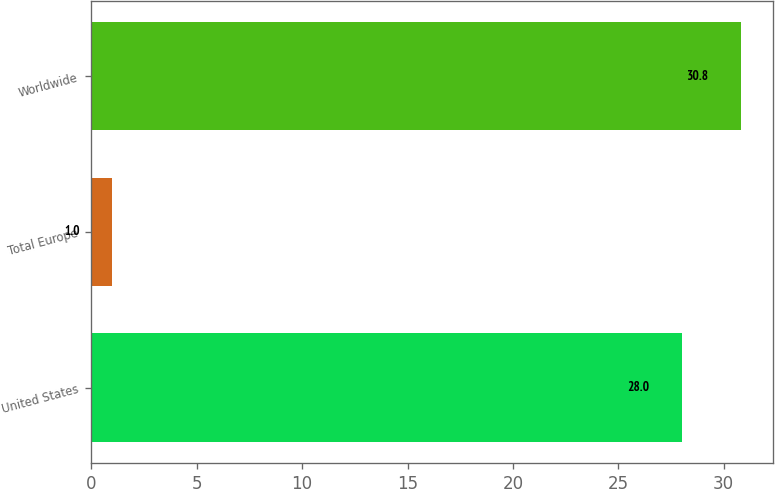Convert chart. <chart><loc_0><loc_0><loc_500><loc_500><bar_chart><fcel>United States<fcel>Total Europe<fcel>Worldwide<nl><fcel>28<fcel>1<fcel>30.8<nl></chart> 